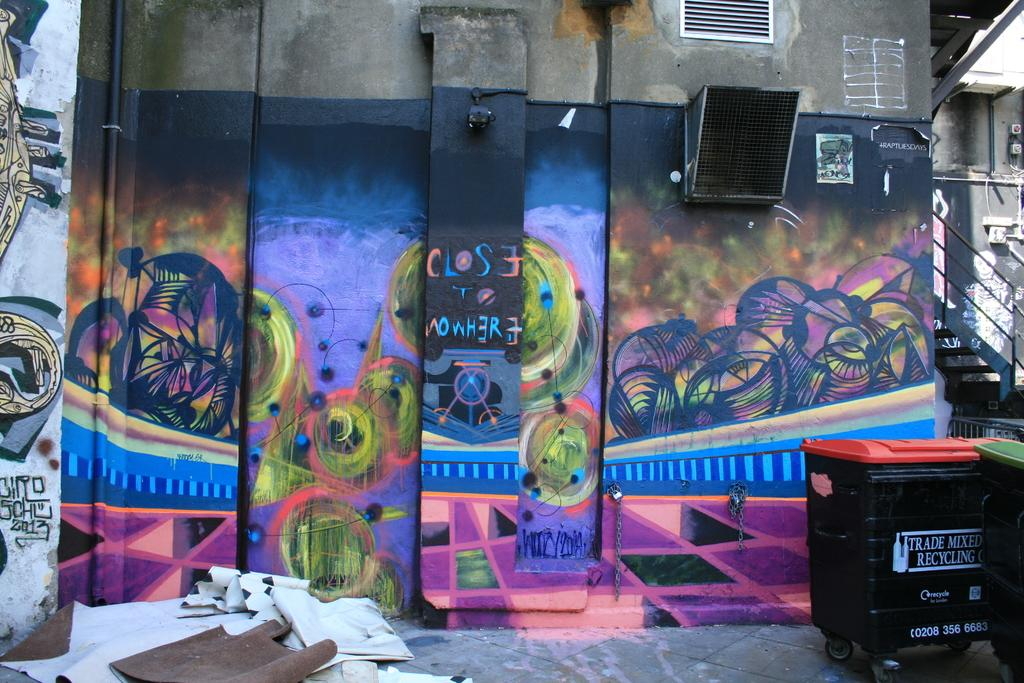<image>
Offer a succinct explanation of the picture presented. In front of a graffiti wall is a bin for trade mixed recycling. 